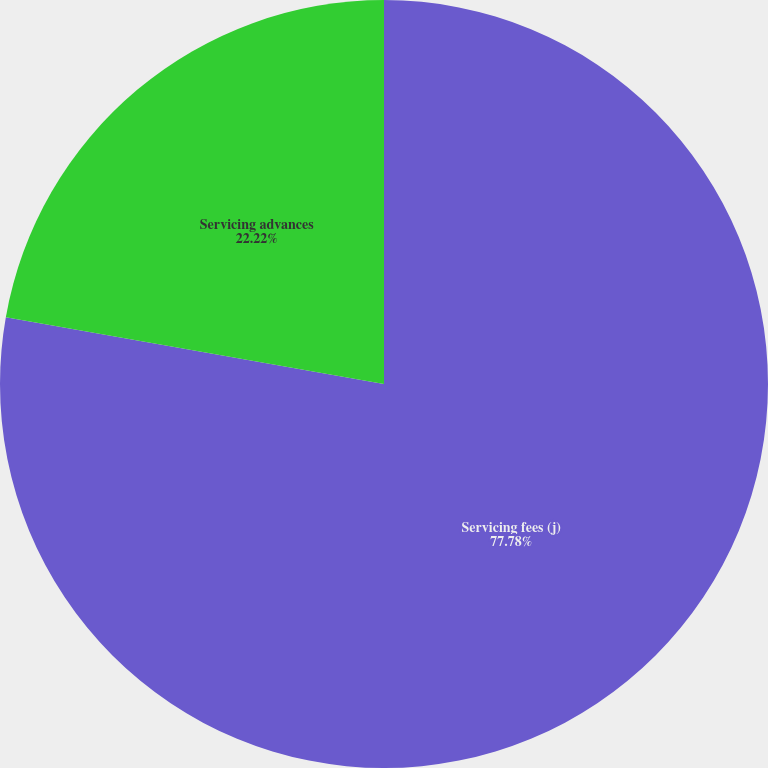Convert chart. <chart><loc_0><loc_0><loc_500><loc_500><pie_chart><fcel>Servicing fees (j)<fcel>Servicing advances<nl><fcel>77.78%<fcel>22.22%<nl></chart> 